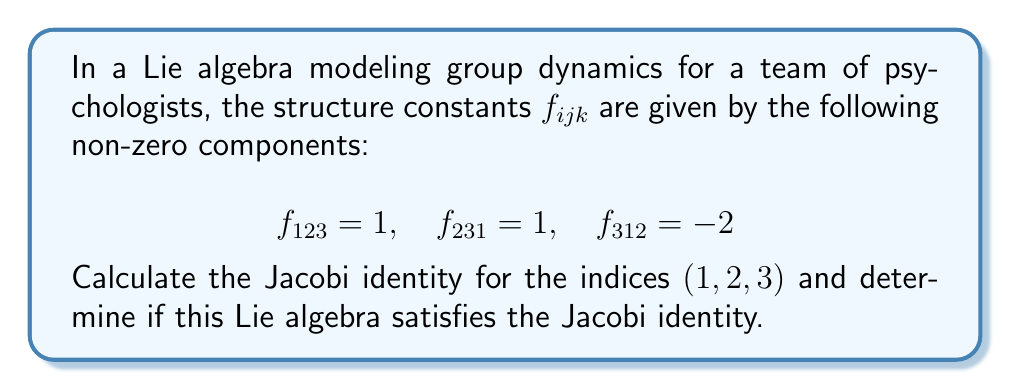Could you help me with this problem? To solve this problem, we need to follow these steps:

1) Recall the Jacobi identity for a Lie algebra:

   $$f_{ijk} + f_{jki} + f_{kij} = 0$$

2) For the indices $(1,2,3)$, we need to calculate:

   $$f_{123} + f_{231} + f_{312}$$

3) Substituting the given values:

   $$f_{123} = 1$$
   $$f_{231} = 1$$
   $$f_{312} = -2$$

4) Now, let's sum these values:

   $$1 + 1 + (-2) = 0$$

5) We can see that the sum is indeed equal to zero.

6) The Jacobi identity is satisfied for the indices $(1,2,3)$.

It's important to note that for a valid Lie algebra, the Jacobi identity must be satisfied for all combinations of indices. However, in this question, we were only asked to check for $(1,2,3)$.

In the context of group dynamics, this Lie algebra could represent the interactions between three different aspects of group behavior. The structure constants describe how these aspects influence each other, and the Jacobi identity ensures that these influences are consistent and balanced across the group.
Answer: The Jacobi identity for indices $(1,2,3)$ is satisfied: $f_{123} + f_{231} + f_{312} = 1 + 1 + (-2) = 0$. Therefore, this Lie algebra satisfies the Jacobi identity for the given indices. 